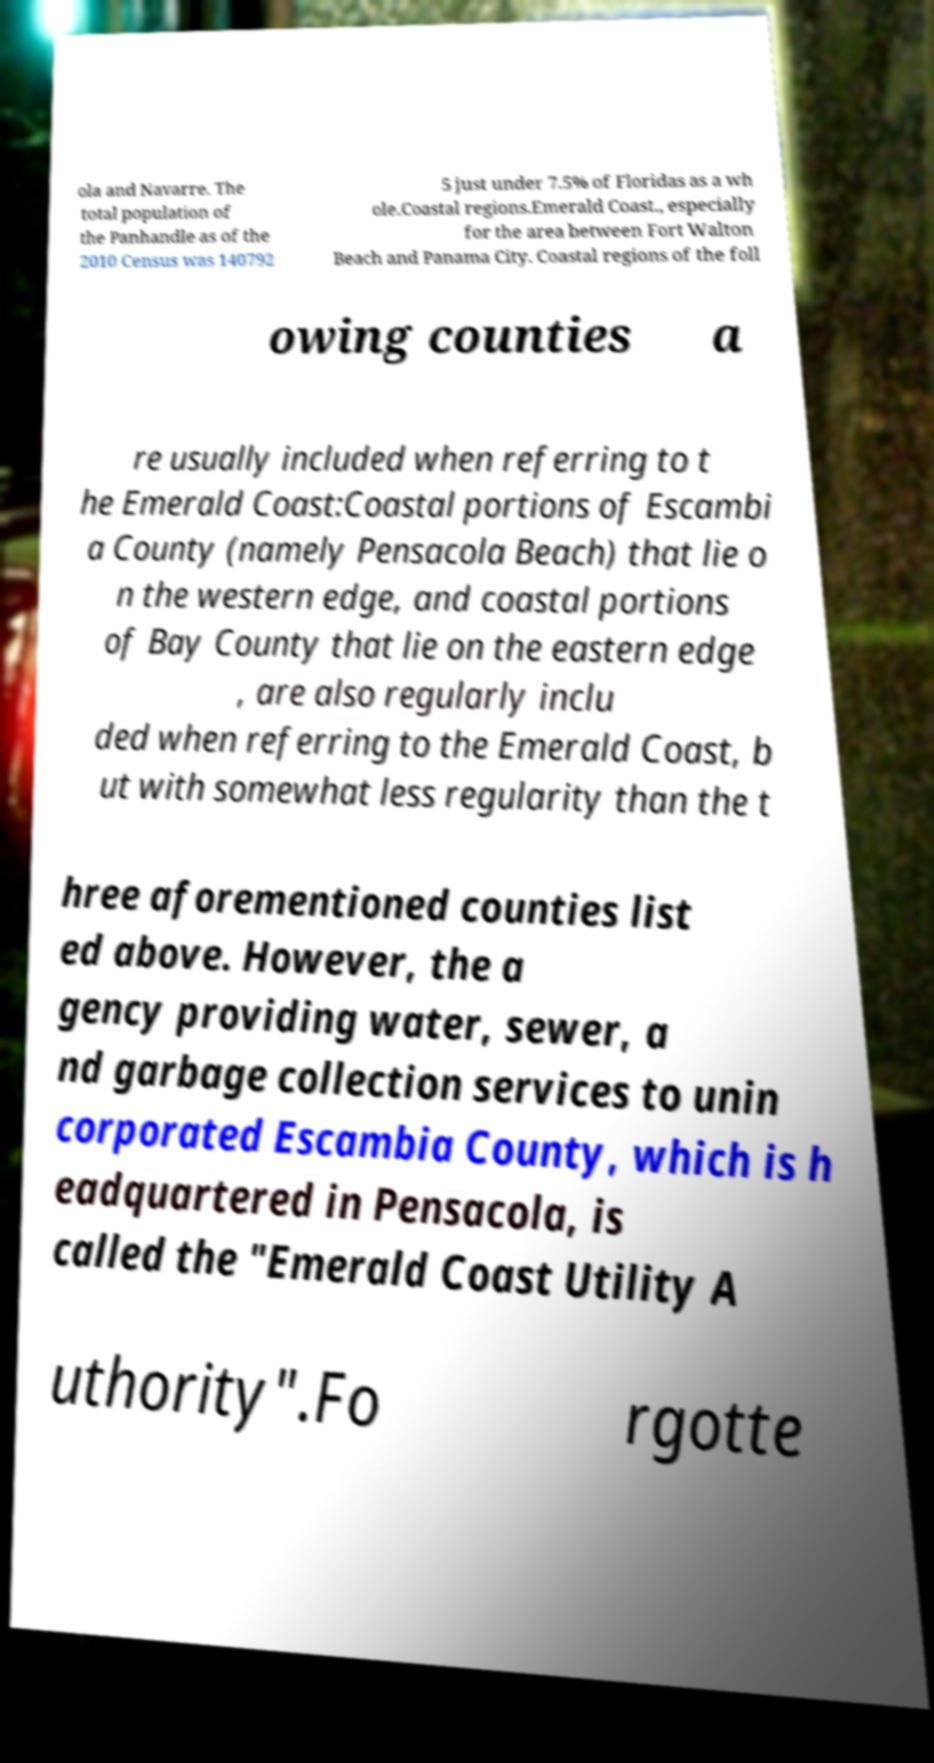Could you assist in decoding the text presented in this image and type it out clearly? ola and Navarre. The total population of the Panhandle as of the 2010 Census was 140792 5 just under 7.5% of Floridas as a wh ole.Coastal regions.Emerald Coast., especially for the area between Fort Walton Beach and Panama City. Coastal regions of the foll owing counties a re usually included when referring to t he Emerald Coast:Coastal portions of Escambi a County (namely Pensacola Beach) that lie o n the western edge, and coastal portions of Bay County that lie on the eastern edge , are also regularly inclu ded when referring to the Emerald Coast, b ut with somewhat less regularity than the t hree aforementioned counties list ed above. However, the a gency providing water, sewer, a nd garbage collection services to unin corporated Escambia County, which is h eadquartered in Pensacola, is called the "Emerald Coast Utility A uthority".Fo rgotte 